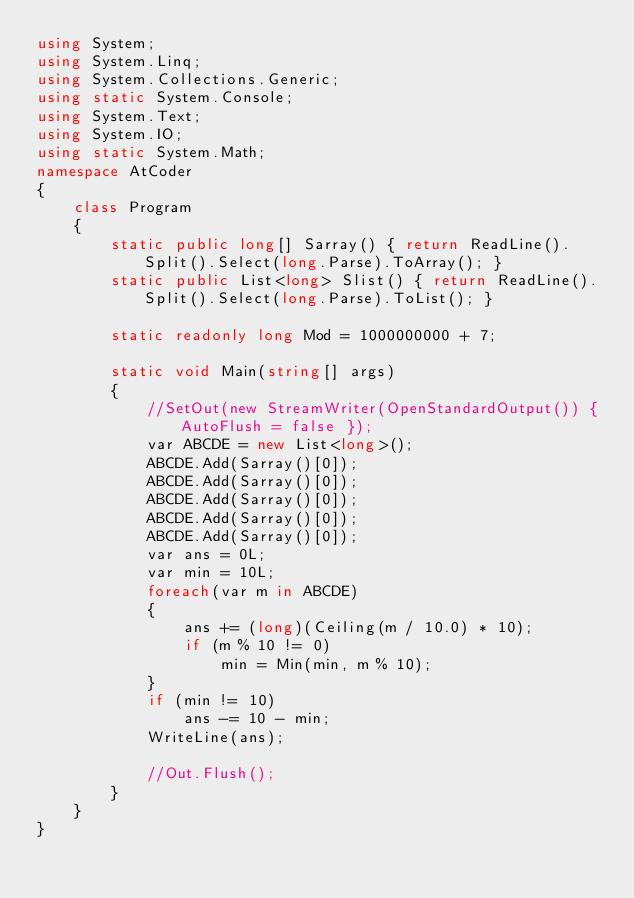<code> <loc_0><loc_0><loc_500><loc_500><_C#_>using System;
using System.Linq;
using System.Collections.Generic;
using static System.Console;
using System.Text;
using System.IO;
using static System.Math;
namespace AtCoder
{
    class Program
    {
        static public long[] Sarray() { return ReadLine().Split().Select(long.Parse).ToArray(); }
        static public List<long> Slist() { return ReadLine().Split().Select(long.Parse).ToList(); }

        static readonly long Mod = 1000000000 + 7;

        static void Main(string[] args)
        {
            //SetOut(new StreamWriter(OpenStandardOutput()) { AutoFlush = false });
            var ABCDE = new List<long>();
            ABCDE.Add(Sarray()[0]);
            ABCDE.Add(Sarray()[0]);
            ABCDE.Add(Sarray()[0]);
            ABCDE.Add(Sarray()[0]);
            ABCDE.Add(Sarray()[0]);
            var ans = 0L;
            var min = 10L;
            foreach(var m in ABCDE)
            {
                ans += (long)(Ceiling(m / 10.0) * 10);
                if (m % 10 != 0)
                    min = Min(min, m % 10);
            }
            if (min != 10)
                ans -= 10 - min;
            WriteLine(ans);

            //Out.Flush();
        }
    }
}</code> 